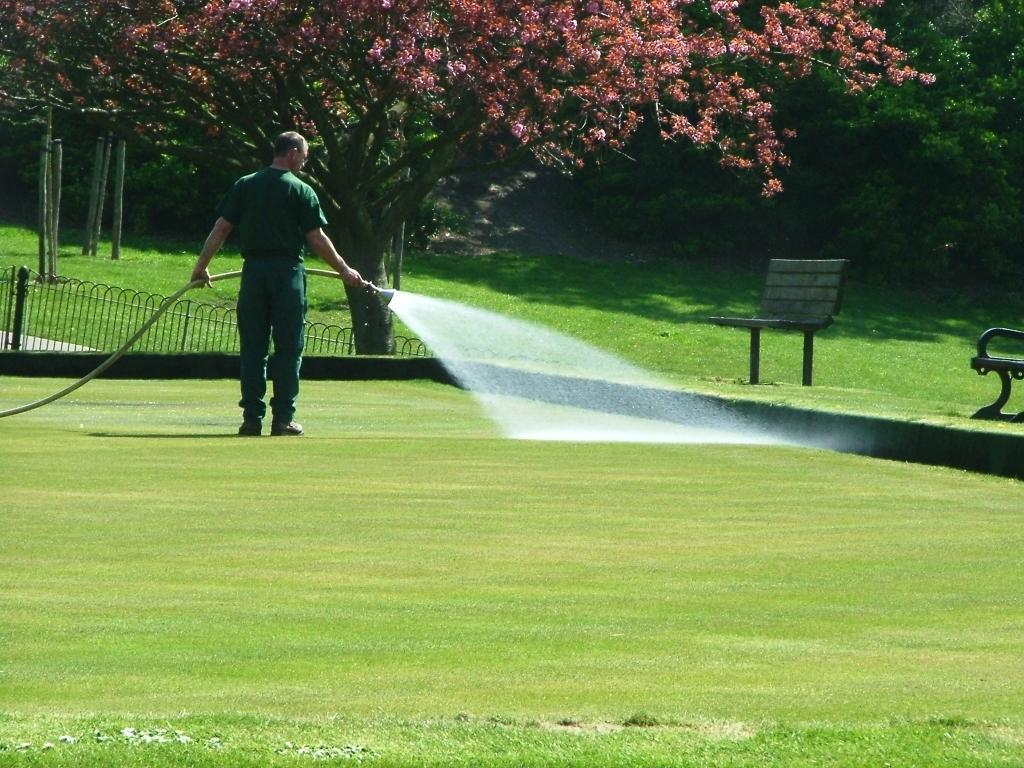What is the man in the image doing? The man is watering the grass. What is the man holding in the image? The man is holding a pipe. What can be seen beside the man in the image? There are two benches beside the man. What is visible in the background of the image? There are trees in the background of the image. How does the horse in the image compare to the man in terms of size? There is no horse present in the image, so it is not possible to make a comparison. 